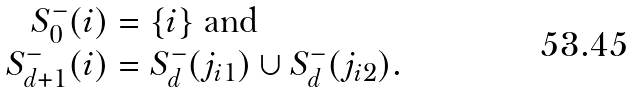<formula> <loc_0><loc_0><loc_500><loc_500>S _ { 0 } ^ { - } ( i ) & = \{ i \} \text { and} \\ S _ { d + 1 } ^ { - } ( i ) & = S _ { d } ^ { - } ( j _ { i 1 } ) \cup S _ { d } ^ { - } ( j _ { i 2 } ) .</formula> 